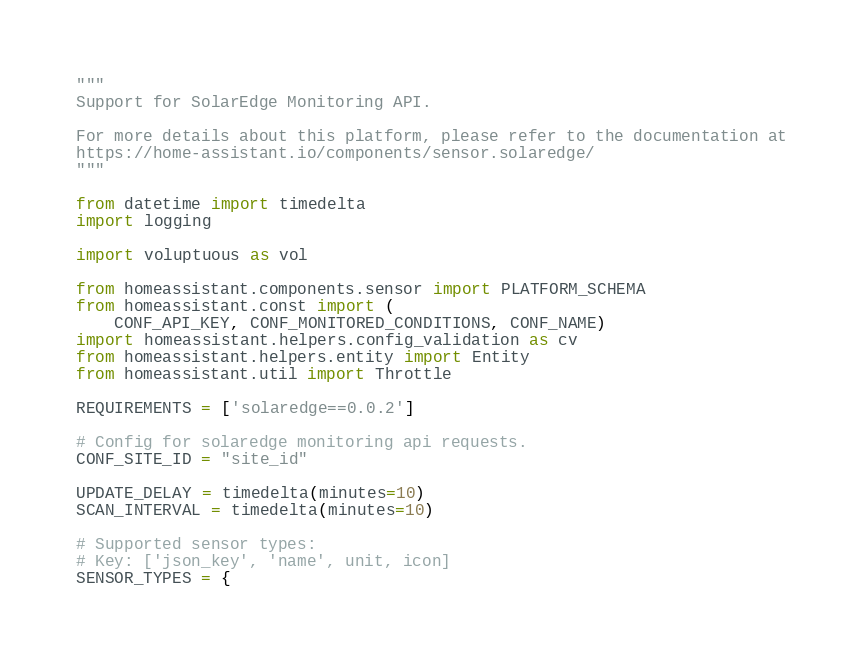<code> <loc_0><loc_0><loc_500><loc_500><_Python_>"""
Support for SolarEdge Monitoring API.

For more details about this platform, please refer to the documentation at
https://home-assistant.io/components/sensor.solaredge/
"""

from datetime import timedelta
import logging

import voluptuous as vol

from homeassistant.components.sensor import PLATFORM_SCHEMA
from homeassistant.const import (
    CONF_API_KEY, CONF_MONITORED_CONDITIONS, CONF_NAME)
import homeassistant.helpers.config_validation as cv
from homeassistant.helpers.entity import Entity
from homeassistant.util import Throttle

REQUIREMENTS = ['solaredge==0.0.2']

# Config for solaredge monitoring api requests.
CONF_SITE_ID = "site_id"

UPDATE_DELAY = timedelta(minutes=10)
SCAN_INTERVAL = timedelta(minutes=10)

# Supported sensor types:
# Key: ['json_key', 'name', unit, icon]
SENSOR_TYPES = {</code> 